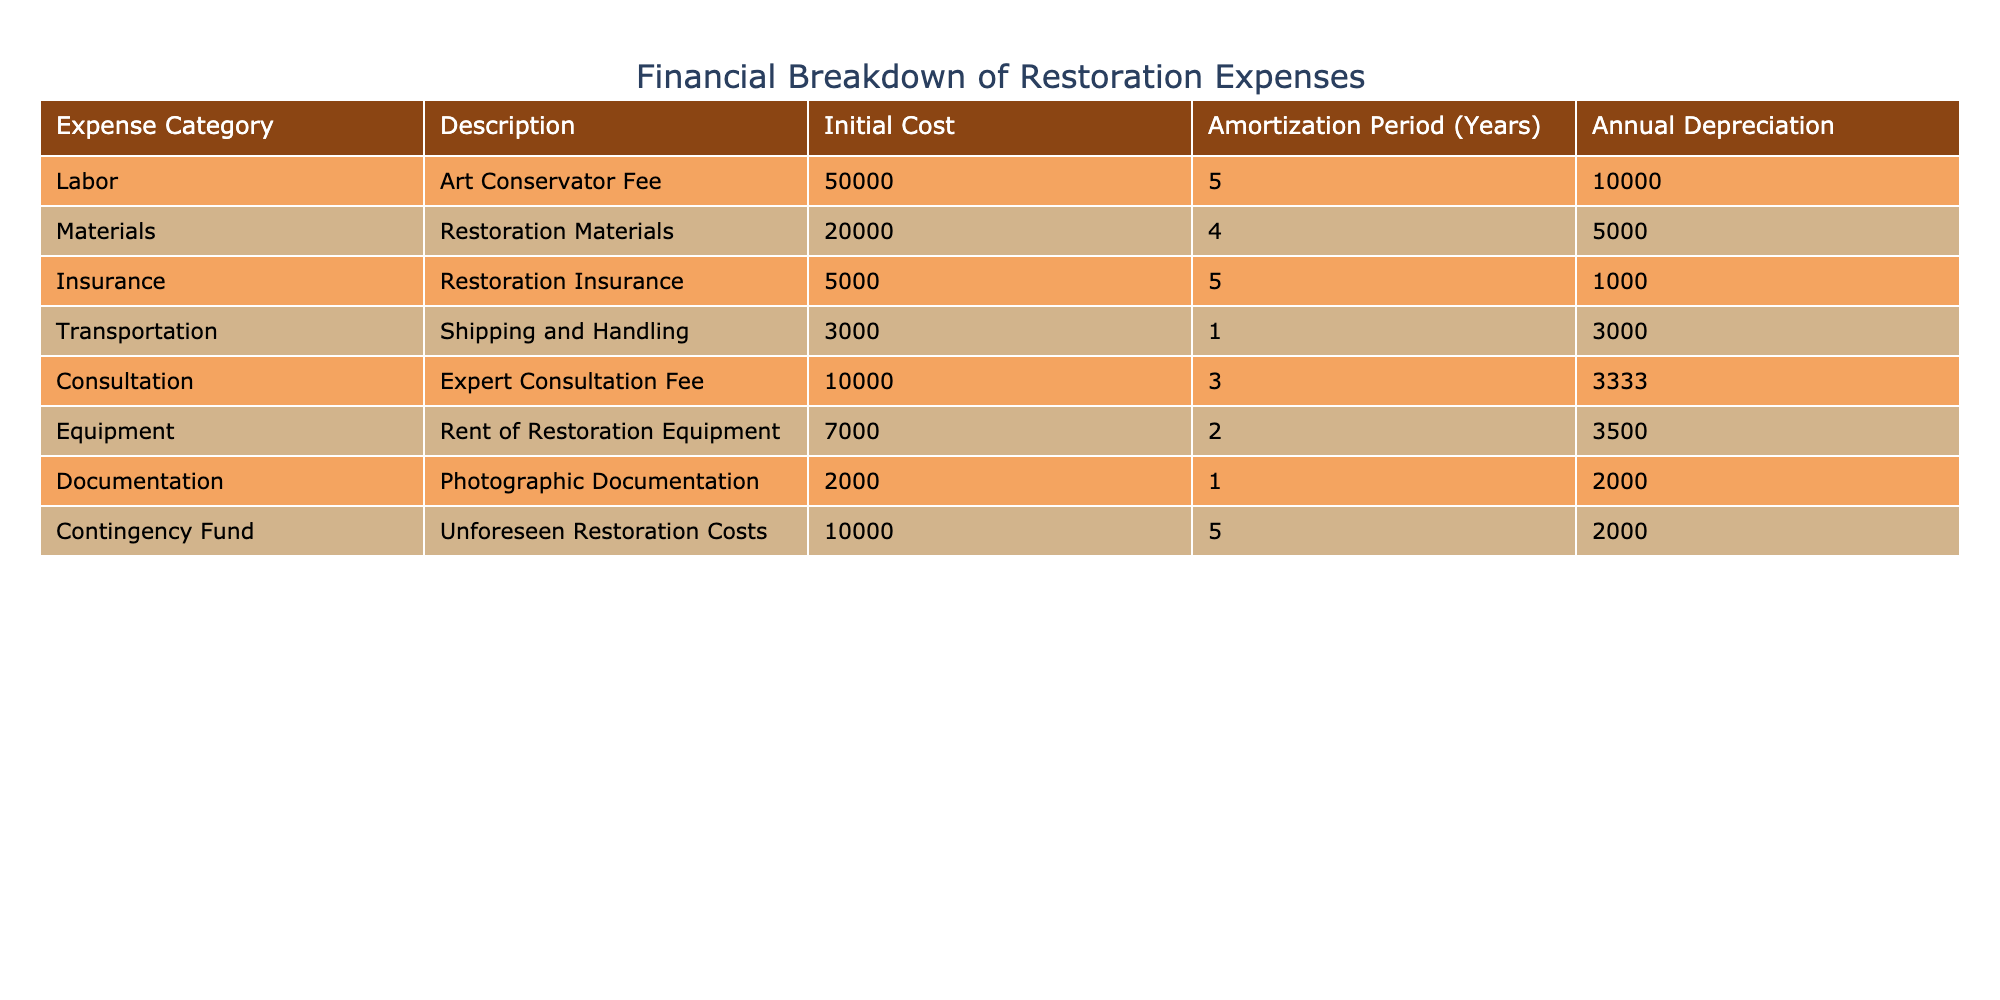What is the total initial cost for the restoration expenses? To find the total initial cost, we need to sum up the initial costs from each expense category: 50000 (Labor) + 20000 (Materials) + 5000 (Insurance) + 3000 (Transportation) + 10000 (Consultation) + 7000 (Equipment) + 2000 (Documentation) + 10000 (Contingency Fund) = 100000.
Answer: 100000 Which expense category has the highest annual depreciation? By looking at the annual depreciation column, we can see that Labor (10000) has the highest annual depreciation compared to others: 10000 (Labor), 5000 (Materials), 1000 (Insurance), 3000 (Transportation), 3333 (Consultation), 3500 (Equipment), 2000 (Documentation), 2000 (Contingency Fund).
Answer: Labor Is the total annual depreciation for all expense categories more than 20000? We first need to sum the annual depreciation values: 10000 (Labor) + 5000 (Materials) + 1000 (Insurance) + 3000 (Transportation) + 3333 (Consultation) + 3500 (Equipment) + 2000 (Documentation) + 2000 (Contingency Fund) = 30000, which is indeed more than 20000.
Answer: Yes What is the average initial cost across all expense categories? To find the average, we first sum the initial costs: 50000 + 20000 + 5000 + 3000 + 10000 + 7000 + 2000 + 10000 = 100000. Then we divide by the number of categories (8): 100000 / 8 = 12500.
Answer: 12500 What proportion of the total initial cost does the Labor expense represent? First, we calculate the total initial cost which is 100000. Labor costs 50000. To find the proportion, we divide the Labor cost by the total: 50000 / 100000 = 0.5 or 50%.
Answer: 50% Which two expense categories together have an initial cost of 30000? The only two categories that sum to 30000 are Transportation (3000) and Materials (20000), which do not directly equal 30000. Reviewing the categories, the combination that gets close is Labor (50000), which exceeds. No two categories fit this criteria.
Answer: No valid combination Are the restoration materials more expensive to restore than the art conservator fee? The initial cost for restoration materials is 20000, and the art conservator fee is 50000. Since 20000 is less than 50000, restoration materials are not more expensive.
Answer: No What is the total initial cost for short-term expense categories (1 year amortization)? The short-term expense categories are Transportation (3000) and Documentation (2000). Adding these together: 3000 + 2000 = 5000.
Answer: 5000 